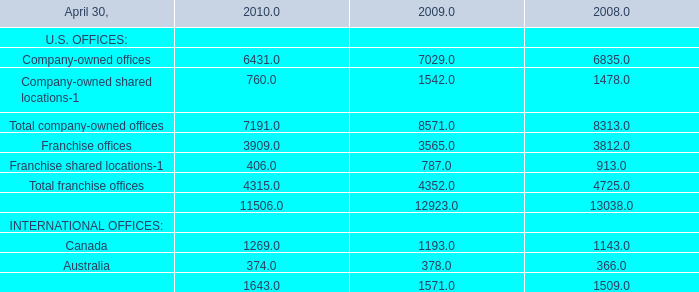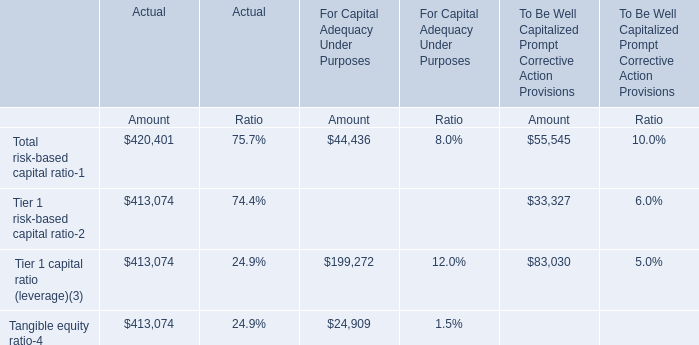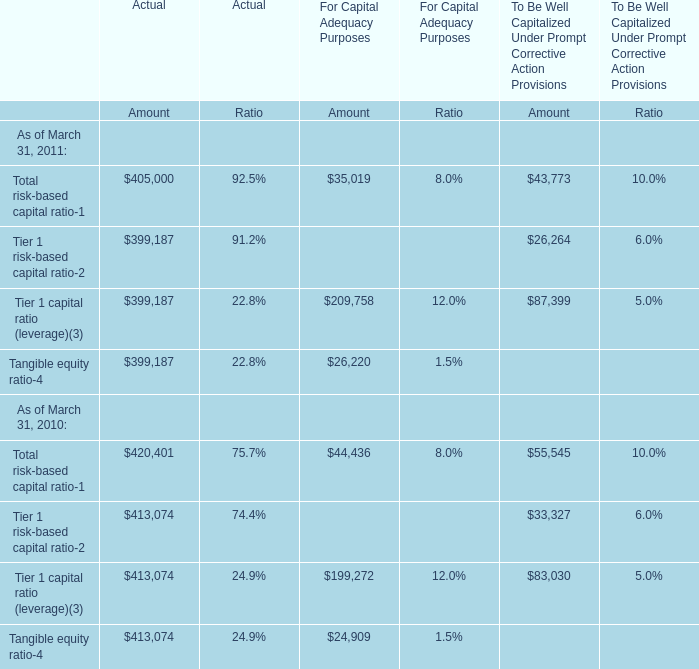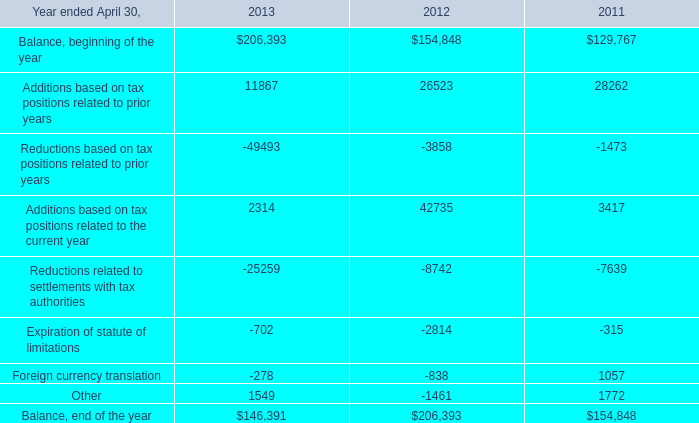At March 31, what year is the Tangible equity ratio in terms of the Amount for Actual larger than 410000? 
Answer: 2010. 